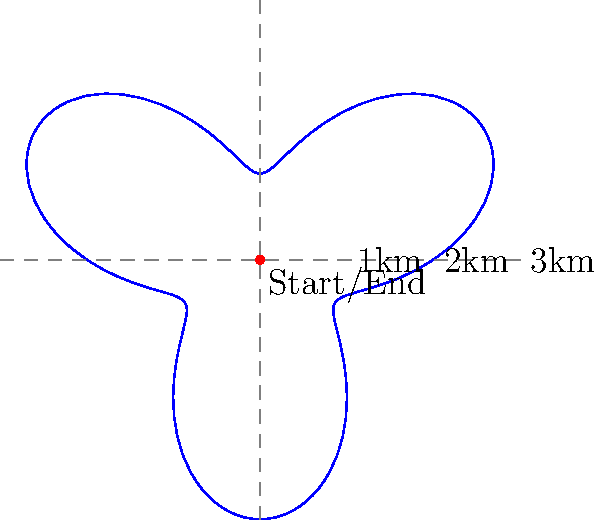A search and rescue dog follows a scent trail that can be modeled using the polar equation $r = 2 + \sin(3\theta)$, where $r$ is measured in kilometers. What is the maximum distance, in kilometers, that the dog travels from the starting point during its search? To find the maximum distance the dog travels from the starting point, we need to follow these steps:

1) The polar equation given is $r = 2 + \sin(3\theta)$.

2) The maximum value of $\sin(3\theta)$ is 1, which occurs when $3\theta = \frac{\pi}{2}, \frac{5\pi}{2}, \frac{9\pi}{2}$, etc.

3) The minimum value of $\sin(3\theta)$ is -1, which occurs when $3\theta = \frac{3\pi}{2}, \frac{7\pi}{2}, \frac{11\pi}{2}$, etc.

4) When $\sin(3\theta)$ is at its maximum (1), the equation becomes:
   $r = 2 + 1 = 3$

5) When $\sin(3\theta)$ is at its minimum (-1), the equation becomes:
   $r = 2 + (-1) = 1$

6) The maximum distance from the starting point occurs when $r$ is at its maximum value, which is 3 kilometers.

Therefore, the maximum distance the dog travels from the starting point during its search is 3 kilometers.
Answer: 3 kilometers 